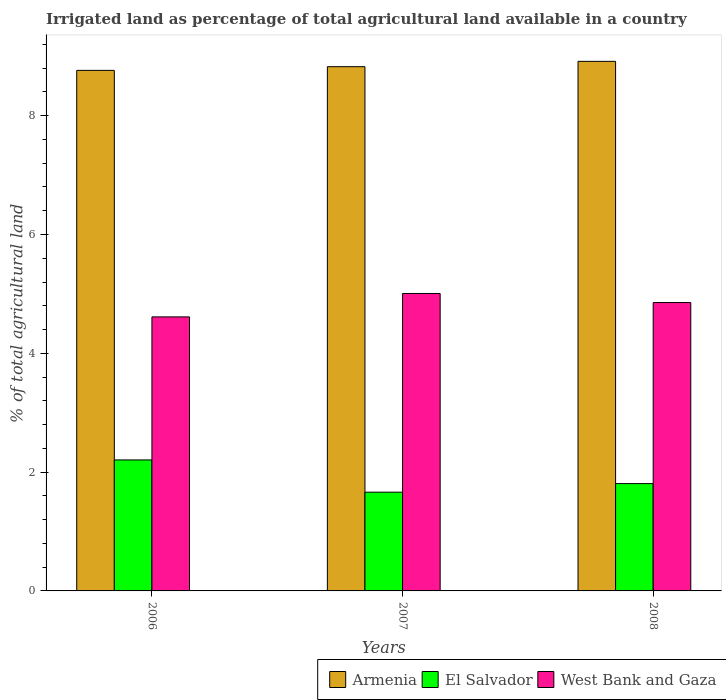How many different coloured bars are there?
Your answer should be very brief. 3. How many bars are there on the 3rd tick from the left?
Ensure brevity in your answer.  3. In how many cases, is the number of bars for a given year not equal to the number of legend labels?
Make the answer very short. 0. What is the percentage of irrigated land in El Salvador in 2006?
Your response must be concise. 2.2. Across all years, what is the maximum percentage of irrigated land in El Salvador?
Provide a succinct answer. 2.2. Across all years, what is the minimum percentage of irrigated land in Armenia?
Provide a short and direct response. 8.76. In which year was the percentage of irrigated land in El Salvador maximum?
Your answer should be compact. 2006. In which year was the percentage of irrigated land in Armenia minimum?
Your response must be concise. 2006. What is the total percentage of irrigated land in El Salvador in the graph?
Your answer should be very brief. 5.67. What is the difference between the percentage of irrigated land in West Bank and Gaza in 2006 and that in 2008?
Keep it short and to the point. -0.24. What is the difference between the percentage of irrigated land in West Bank and Gaza in 2008 and the percentage of irrigated land in Armenia in 2007?
Your answer should be very brief. -3.97. What is the average percentage of irrigated land in Armenia per year?
Make the answer very short. 8.83. In the year 2008, what is the difference between the percentage of irrigated land in West Bank and Gaza and percentage of irrigated land in Armenia?
Provide a succinct answer. -4.06. What is the ratio of the percentage of irrigated land in El Salvador in 2007 to that in 2008?
Offer a terse response. 0.92. Is the difference between the percentage of irrigated land in West Bank and Gaza in 2006 and 2007 greater than the difference between the percentage of irrigated land in Armenia in 2006 and 2007?
Provide a short and direct response. No. What is the difference between the highest and the second highest percentage of irrigated land in Armenia?
Provide a succinct answer. 0.09. What is the difference between the highest and the lowest percentage of irrigated land in El Salvador?
Give a very brief answer. 0.54. In how many years, is the percentage of irrigated land in Armenia greater than the average percentage of irrigated land in Armenia taken over all years?
Ensure brevity in your answer.  1. What does the 3rd bar from the left in 2007 represents?
Offer a very short reply. West Bank and Gaza. What does the 1st bar from the right in 2008 represents?
Provide a short and direct response. West Bank and Gaza. How many bars are there?
Your response must be concise. 9. Are all the bars in the graph horizontal?
Your answer should be very brief. No. What is the difference between two consecutive major ticks on the Y-axis?
Keep it short and to the point. 2. Does the graph contain any zero values?
Offer a terse response. No. Does the graph contain grids?
Ensure brevity in your answer.  No. Where does the legend appear in the graph?
Provide a succinct answer. Bottom right. How many legend labels are there?
Offer a very short reply. 3. What is the title of the graph?
Offer a terse response. Irrigated land as percentage of total agricultural land available in a country. What is the label or title of the Y-axis?
Keep it short and to the point. % of total agricultural land. What is the % of total agricultural land in Armenia in 2006?
Keep it short and to the point. 8.76. What is the % of total agricultural land of El Salvador in 2006?
Keep it short and to the point. 2.2. What is the % of total agricultural land of West Bank and Gaza in 2006?
Ensure brevity in your answer.  4.61. What is the % of total agricultural land in Armenia in 2007?
Keep it short and to the point. 8.82. What is the % of total agricultural land in El Salvador in 2007?
Offer a very short reply. 1.66. What is the % of total agricultural land of West Bank and Gaza in 2007?
Offer a very short reply. 5.01. What is the % of total agricultural land in Armenia in 2008?
Your answer should be compact. 8.91. What is the % of total agricultural land in El Salvador in 2008?
Give a very brief answer. 1.81. What is the % of total agricultural land in West Bank and Gaza in 2008?
Your answer should be very brief. 4.85. Across all years, what is the maximum % of total agricultural land of Armenia?
Provide a succinct answer. 8.91. Across all years, what is the maximum % of total agricultural land in El Salvador?
Provide a short and direct response. 2.2. Across all years, what is the maximum % of total agricultural land of West Bank and Gaza?
Your answer should be very brief. 5.01. Across all years, what is the minimum % of total agricultural land of Armenia?
Offer a very short reply. 8.76. Across all years, what is the minimum % of total agricultural land of El Salvador?
Keep it short and to the point. 1.66. Across all years, what is the minimum % of total agricultural land of West Bank and Gaza?
Your answer should be compact. 4.61. What is the total % of total agricultural land in Armenia in the graph?
Offer a very short reply. 26.5. What is the total % of total agricultural land of El Salvador in the graph?
Your answer should be compact. 5.67. What is the total % of total agricultural land in West Bank and Gaza in the graph?
Keep it short and to the point. 14.47. What is the difference between the % of total agricultural land of Armenia in 2006 and that in 2007?
Your response must be concise. -0.06. What is the difference between the % of total agricultural land of El Salvador in 2006 and that in 2007?
Provide a succinct answer. 0.54. What is the difference between the % of total agricultural land of West Bank and Gaza in 2006 and that in 2007?
Keep it short and to the point. -0.39. What is the difference between the % of total agricultural land in Armenia in 2006 and that in 2008?
Provide a succinct answer. -0.15. What is the difference between the % of total agricultural land in El Salvador in 2006 and that in 2008?
Keep it short and to the point. 0.4. What is the difference between the % of total agricultural land of West Bank and Gaza in 2006 and that in 2008?
Keep it short and to the point. -0.24. What is the difference between the % of total agricultural land of Armenia in 2007 and that in 2008?
Give a very brief answer. -0.09. What is the difference between the % of total agricultural land of El Salvador in 2007 and that in 2008?
Ensure brevity in your answer.  -0.14. What is the difference between the % of total agricultural land of West Bank and Gaza in 2007 and that in 2008?
Your response must be concise. 0.15. What is the difference between the % of total agricultural land in Armenia in 2006 and the % of total agricultural land in El Salvador in 2007?
Offer a terse response. 7.1. What is the difference between the % of total agricultural land of Armenia in 2006 and the % of total agricultural land of West Bank and Gaza in 2007?
Your answer should be compact. 3.76. What is the difference between the % of total agricultural land in El Salvador in 2006 and the % of total agricultural land in West Bank and Gaza in 2007?
Make the answer very short. -2.8. What is the difference between the % of total agricultural land in Armenia in 2006 and the % of total agricultural land in El Salvador in 2008?
Ensure brevity in your answer.  6.96. What is the difference between the % of total agricultural land in Armenia in 2006 and the % of total agricultural land in West Bank and Gaza in 2008?
Keep it short and to the point. 3.91. What is the difference between the % of total agricultural land in El Salvador in 2006 and the % of total agricultural land in West Bank and Gaza in 2008?
Your answer should be compact. -2.65. What is the difference between the % of total agricultural land in Armenia in 2007 and the % of total agricultural land in El Salvador in 2008?
Offer a terse response. 7.02. What is the difference between the % of total agricultural land in Armenia in 2007 and the % of total agricultural land in West Bank and Gaza in 2008?
Offer a very short reply. 3.97. What is the difference between the % of total agricultural land in El Salvador in 2007 and the % of total agricultural land in West Bank and Gaza in 2008?
Ensure brevity in your answer.  -3.19. What is the average % of total agricultural land of Armenia per year?
Provide a short and direct response. 8.83. What is the average % of total agricultural land of El Salvador per year?
Offer a very short reply. 1.89. What is the average % of total agricultural land of West Bank and Gaza per year?
Offer a very short reply. 4.82. In the year 2006, what is the difference between the % of total agricultural land of Armenia and % of total agricultural land of El Salvador?
Offer a terse response. 6.56. In the year 2006, what is the difference between the % of total agricultural land of Armenia and % of total agricultural land of West Bank and Gaza?
Offer a very short reply. 4.15. In the year 2006, what is the difference between the % of total agricultural land in El Salvador and % of total agricultural land in West Bank and Gaza?
Make the answer very short. -2.41. In the year 2007, what is the difference between the % of total agricultural land in Armenia and % of total agricultural land in El Salvador?
Your answer should be very brief. 7.16. In the year 2007, what is the difference between the % of total agricultural land in Armenia and % of total agricultural land in West Bank and Gaza?
Your answer should be compact. 3.82. In the year 2007, what is the difference between the % of total agricultural land in El Salvador and % of total agricultural land in West Bank and Gaza?
Your answer should be very brief. -3.34. In the year 2008, what is the difference between the % of total agricultural land in Armenia and % of total agricultural land in El Salvador?
Provide a short and direct response. 7.11. In the year 2008, what is the difference between the % of total agricultural land of Armenia and % of total agricultural land of West Bank and Gaza?
Your answer should be compact. 4.06. In the year 2008, what is the difference between the % of total agricultural land in El Salvador and % of total agricultural land in West Bank and Gaza?
Provide a short and direct response. -3.05. What is the ratio of the % of total agricultural land in El Salvador in 2006 to that in 2007?
Make the answer very short. 1.33. What is the ratio of the % of total agricultural land in West Bank and Gaza in 2006 to that in 2007?
Ensure brevity in your answer.  0.92. What is the ratio of the % of total agricultural land of Armenia in 2006 to that in 2008?
Provide a short and direct response. 0.98. What is the ratio of the % of total agricultural land in El Salvador in 2006 to that in 2008?
Your answer should be compact. 1.22. What is the ratio of the % of total agricultural land of West Bank and Gaza in 2006 to that in 2008?
Ensure brevity in your answer.  0.95. What is the ratio of the % of total agricultural land of El Salvador in 2007 to that in 2008?
Provide a succinct answer. 0.92. What is the ratio of the % of total agricultural land in West Bank and Gaza in 2007 to that in 2008?
Your answer should be very brief. 1.03. What is the difference between the highest and the second highest % of total agricultural land in Armenia?
Your answer should be compact. 0.09. What is the difference between the highest and the second highest % of total agricultural land of El Salvador?
Give a very brief answer. 0.4. What is the difference between the highest and the second highest % of total agricultural land in West Bank and Gaza?
Keep it short and to the point. 0.15. What is the difference between the highest and the lowest % of total agricultural land of Armenia?
Provide a succinct answer. 0.15. What is the difference between the highest and the lowest % of total agricultural land of El Salvador?
Your answer should be compact. 0.54. What is the difference between the highest and the lowest % of total agricultural land of West Bank and Gaza?
Offer a terse response. 0.39. 